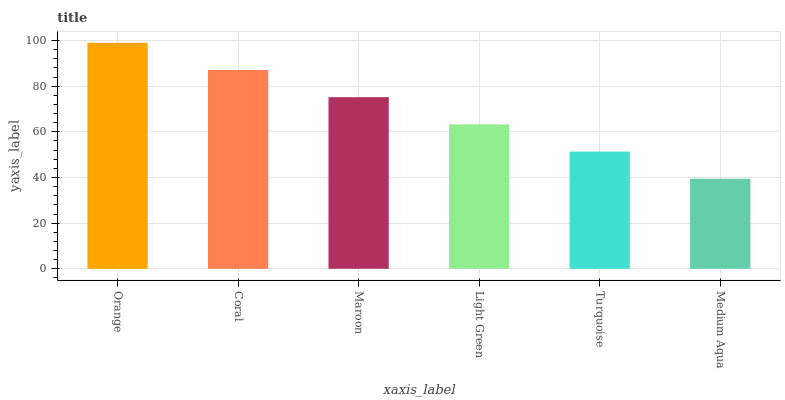Is Medium Aqua the minimum?
Answer yes or no. Yes. Is Orange the maximum?
Answer yes or no. Yes. Is Coral the minimum?
Answer yes or no. No. Is Coral the maximum?
Answer yes or no. No. Is Orange greater than Coral?
Answer yes or no. Yes. Is Coral less than Orange?
Answer yes or no. Yes. Is Coral greater than Orange?
Answer yes or no. No. Is Orange less than Coral?
Answer yes or no. No. Is Maroon the high median?
Answer yes or no. Yes. Is Light Green the low median?
Answer yes or no. Yes. Is Medium Aqua the high median?
Answer yes or no. No. Is Coral the low median?
Answer yes or no. No. 